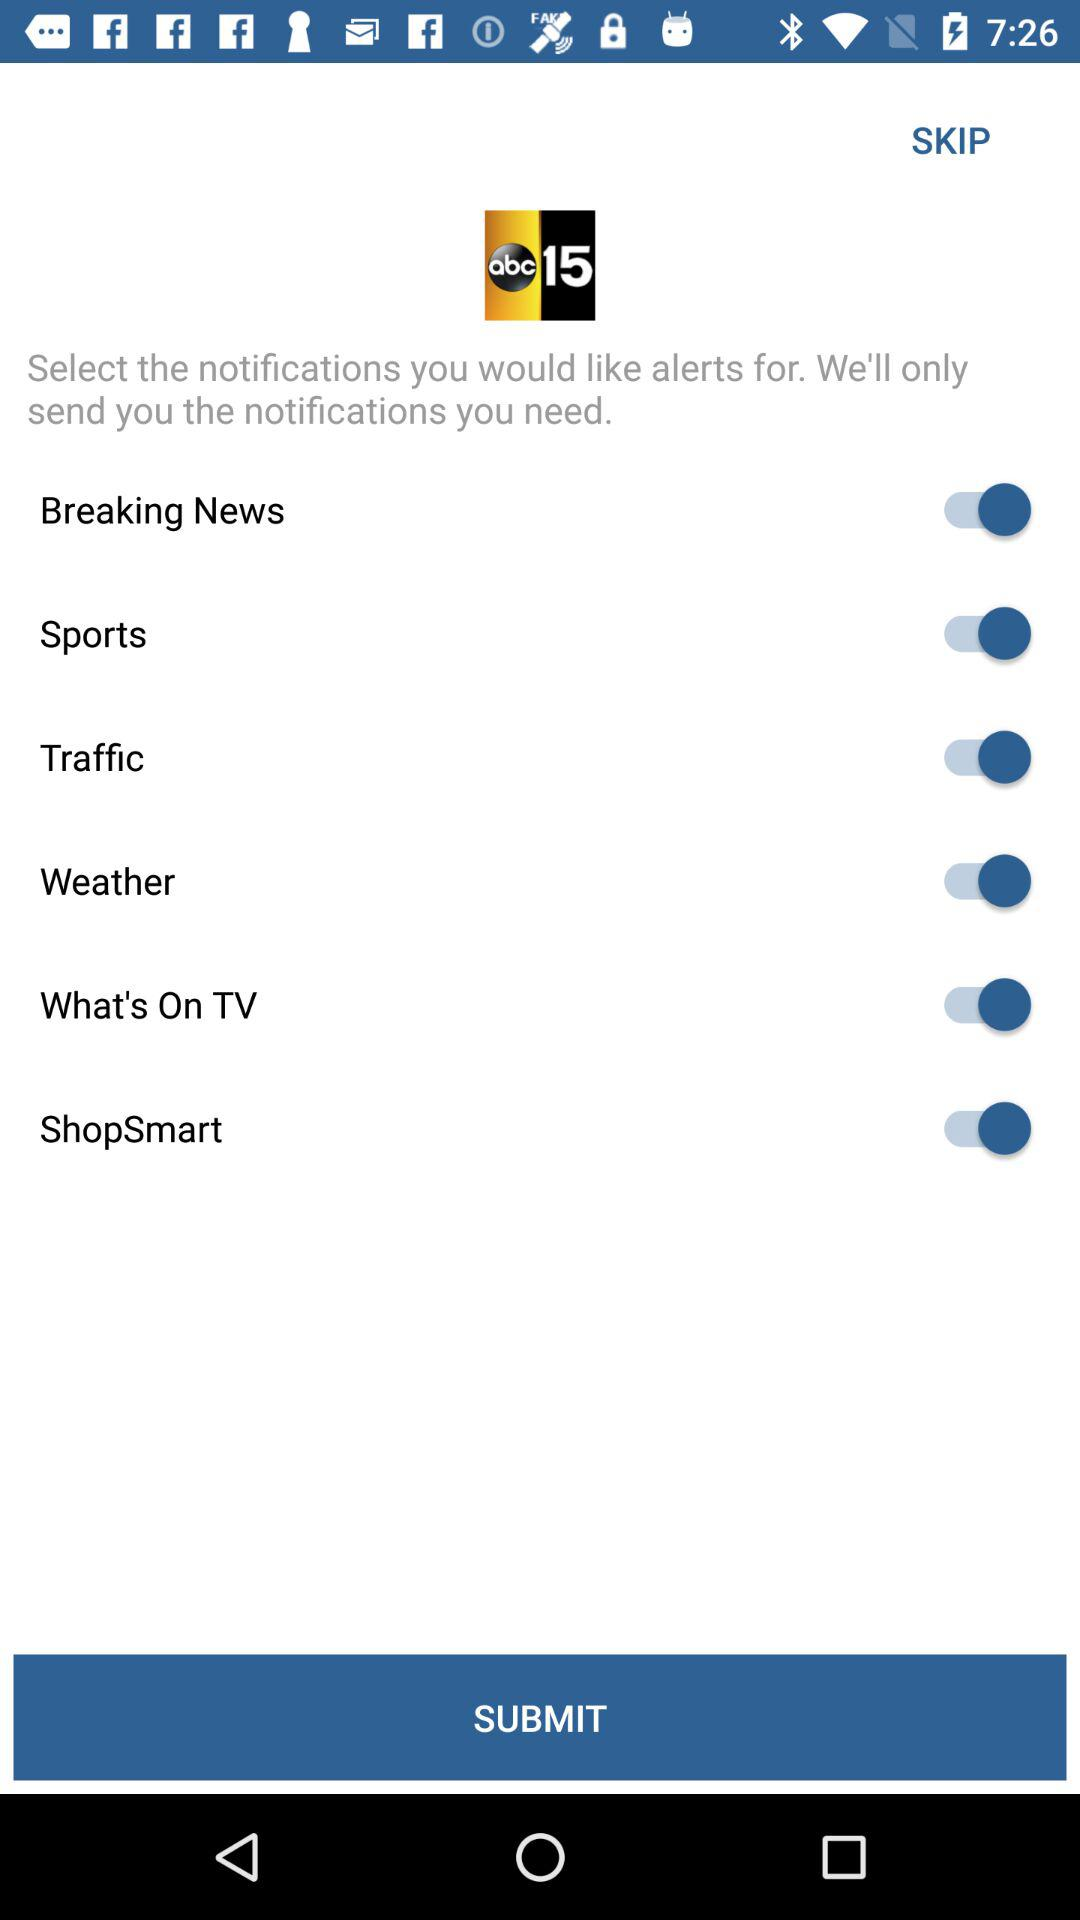What is the name of the application? The name of the application is "ABC15". 